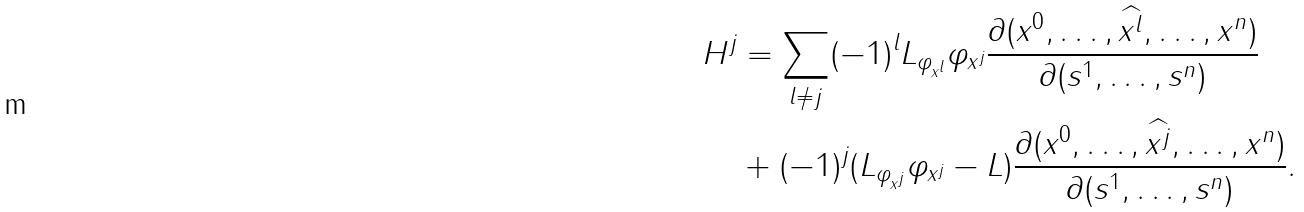Convert formula to latex. <formula><loc_0><loc_0><loc_500><loc_500>{ } H ^ { j } & = \sum _ { l \ne j } ( - 1 ) ^ { l } L _ { \varphi _ { x ^ { l } } } \varphi _ { x ^ { j } } \frac { \partial ( x ^ { 0 } , \dots , \widehat { x ^ { l } } , \dots , x ^ { n } ) } { \partial ( s ^ { 1 } , \dots , s ^ { n } ) } \\ & + ( - 1 ) ^ { j } ( L _ { \varphi _ { x ^ { j } } } \varphi _ { x ^ { j } } - L ) \frac { \partial ( x ^ { 0 } , \dots , \widehat { x ^ { j } } , \dots , x ^ { n } ) } { \partial ( s ^ { 1 } , \dots , s ^ { n } ) } .</formula> 